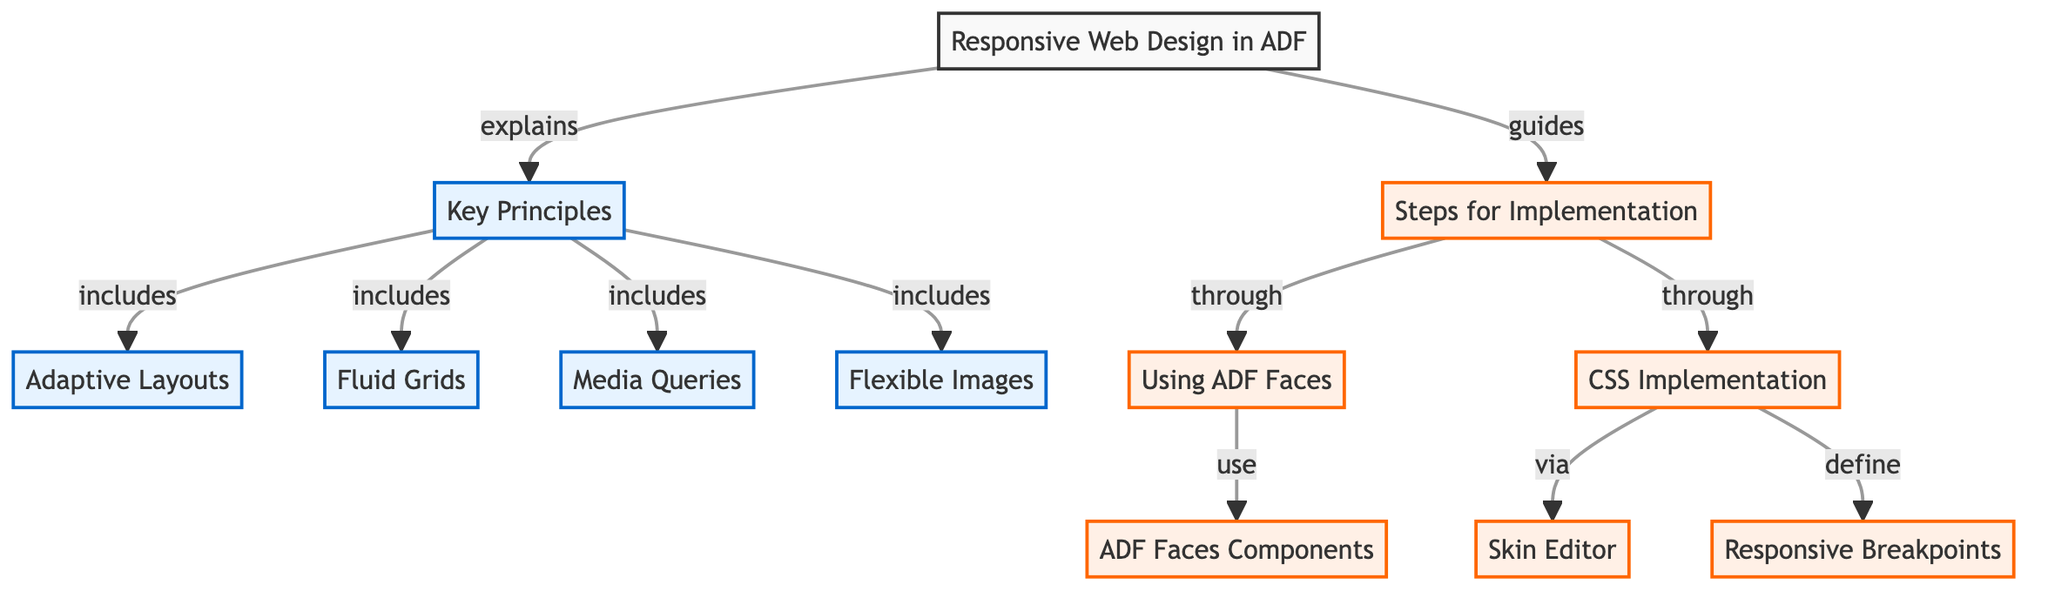What are the key principles of responsive web design in ADF? The diagram lists four key principles under the node "Key Principles," which include Adaptive Layouts, Fluid Grids, Media Queries, and Flexible Images. These principles focus on how to create responsive designs that adapt to different device sizes and orientations.
Answer: Adaptive Layouts, Fluid Grids, Media Queries, Flexible Images How many steps are there for implementing responsive design? The "Steps for Implementation" node connects to two sub-nodes: "Using ADF Faces" and "CSS Implementation." This indicates there are two main steps outlined for implementing responsive design in the context of Oracle ADF.
Answer: 2 Which component is used under "Using ADF Faces"? The diagram connects "Using ADF Faces" to "ADF Faces Components," highlighting that one of the steps for implementation involves utilizing specific components provided by ADF Faces for responsive design.
Answer: ADF Faces Components What does the CSS Implementation node connect to? The "CSS Implementation" node connects to two sub-nodes: "Skin Editor" and "Responsive Breakpoints." This reveals that CSS implementation includes working with these two specific aspects in the context of responsive design.
Answer: Skin Editor, Responsive Breakpoints What are the four principles of responsive web design listed in the diagram? The principles are presented in a list format under the "Key Principles" node and include Adaptive Layouts, Fluid Grids, Media Queries, and Flexible Images, indicating the core strategies for achieving responsive design.
Answer: Adaptive Layouts, Fluid Grids, Media Queries, Flexible Images How does "Responsive Web Design in ADF" relate to "Steps for Implementation"? The diagram shows a directed edge from the "Responsive Web Design in ADF" node to the "Steps for Implementation" node, indicating that it serves as a guide or foundational concept from which implementation steps are derived.
Answer: Guides What function do media queries serve according to the diagram? Media Queries are listed under the Key Principles. This indicates that their function is to facilitate responsive design by allowing styles to be applied based on specific conditions such as screen size or device orientation.
Answer: Conditions 